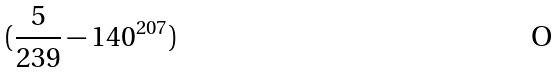<formula> <loc_0><loc_0><loc_500><loc_500>( \frac { 5 } { 2 3 9 } - 1 4 0 ^ { 2 0 7 } )</formula> 